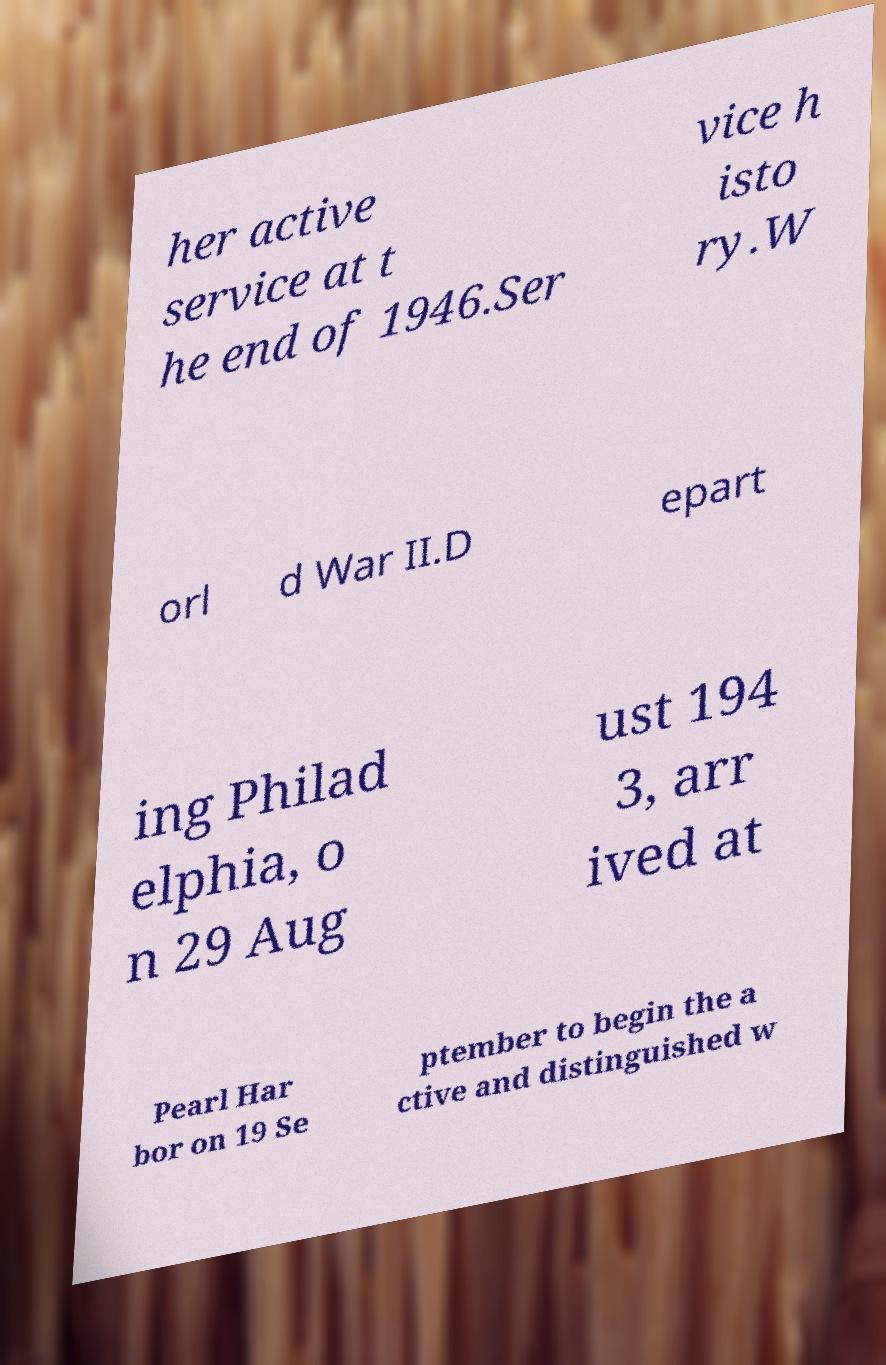For documentation purposes, I need the text within this image transcribed. Could you provide that? her active service at t he end of 1946.Ser vice h isto ry.W orl d War II.D epart ing Philad elphia, o n 29 Aug ust 194 3, arr ived at Pearl Har bor on 19 Se ptember to begin the a ctive and distinguished w 